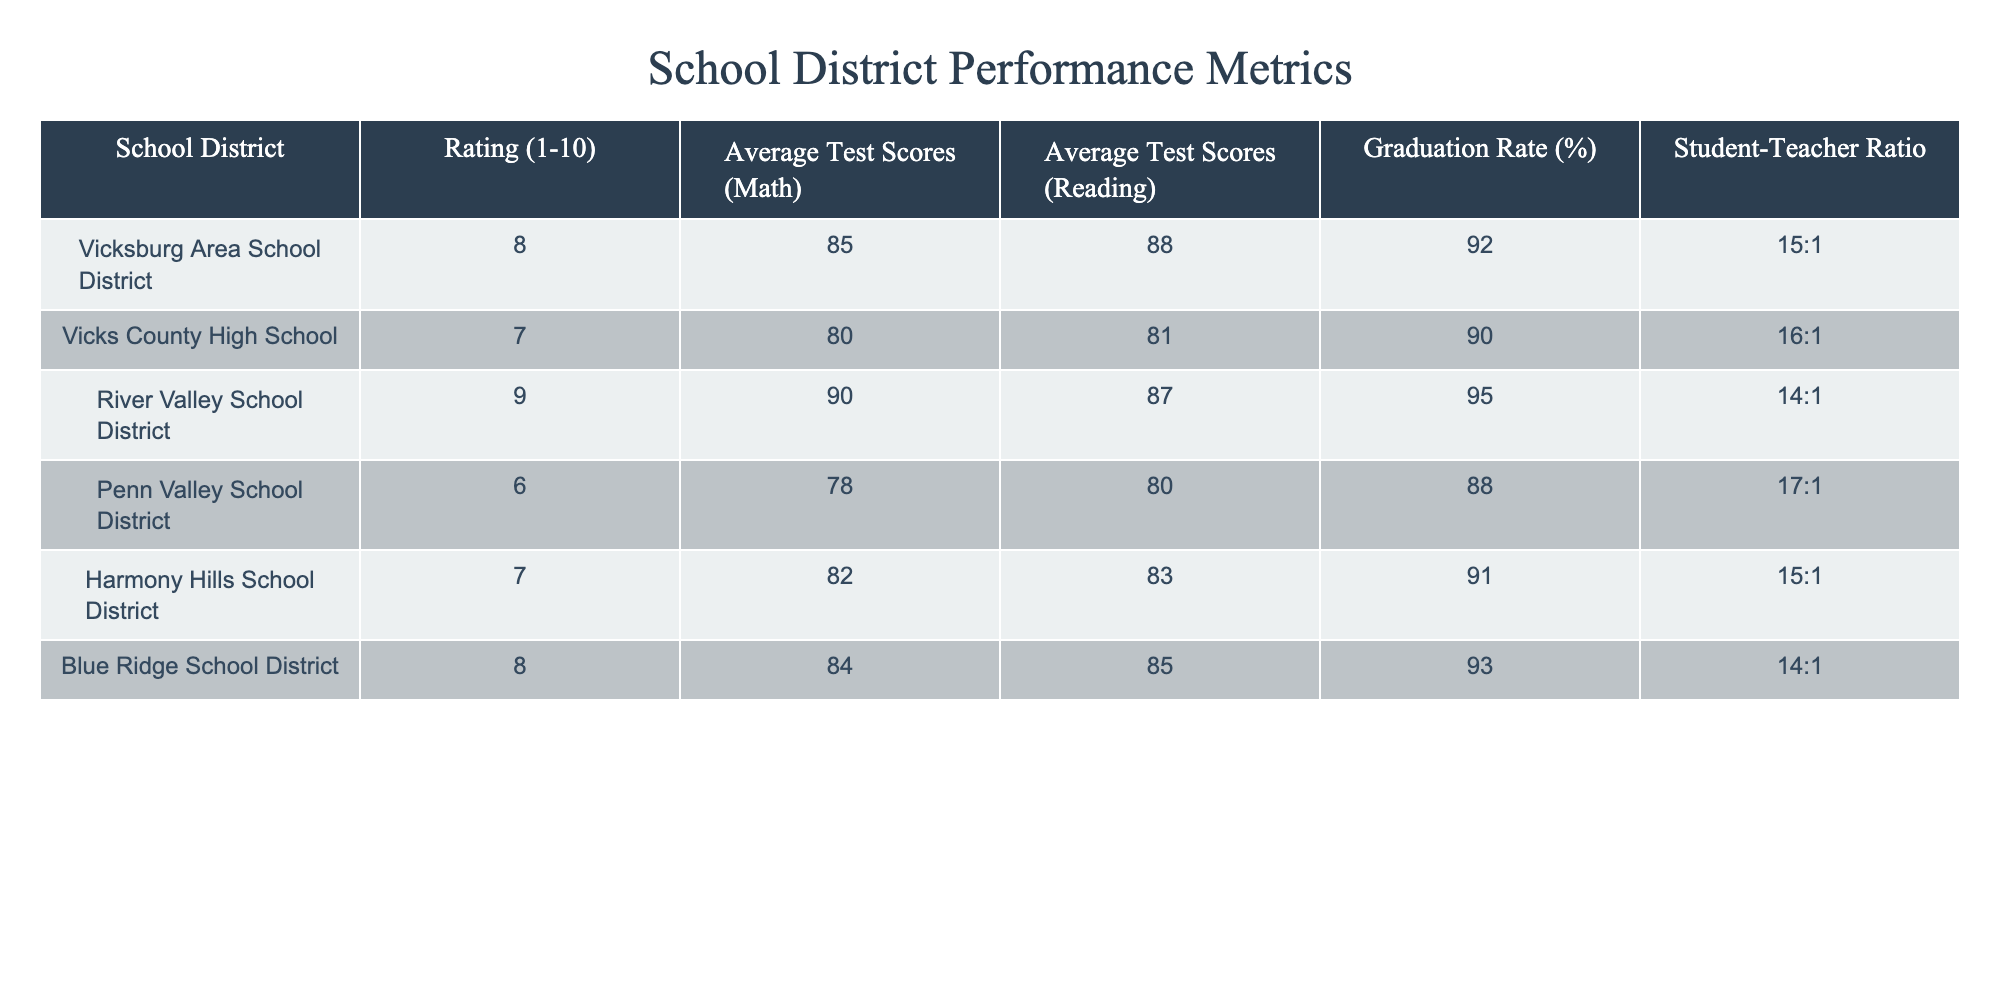What is the highest graduation rate among the school districts? The graduation rates for the districts are 92%, 90%, 95%, 88%, 91%, and 93%. The highest is 95% from the River Valley School District.
Answer: 95% What is the average student-teacher ratio across all districts? The student-teacher ratios are 15:1, 16:1, 14:1, 17:1, 15:1, and 14:1. Converting these to decimals: 15, 16, 14, 17, 15, 14. The sum is 91. There are 6 districts, so the average is 91/6 = 15.17.
Answer: 15.17 Is the Vicksburg Area School District rated higher than the Vicks County High School? The Vicksburg Area School District has a rating of 8, while Vicks County High School has a rating of 7. Since 8 is greater than 7, the statement is true.
Answer: Yes Which school district has the second highest average reading score? The average reading scores are 88, 81, 87, 80, 83, and 85. The highest is 90, followed by 88 for Vicksburg Area School District. The second highest is 87 for River Valley School District.
Answer: River Valley School District What is the difference in average math scores between the highest and lowest rated school districts? The highest math score is 90 from the River Valley School District and the lowest is 78 from Penn Valley School District. The difference is 90 - 78 = 12.
Answer: 12 Does any school district have a graduation rate of less than 90%? The graduation rates are 92%, 90%, 95%, 88%, 91%, and 93%. The only one under 90% is the Penn Valley School District with a graduation rate of 88%.
Answer: Yes What is the average test score in math for districts rated 7 or lower? The math scores for districts rated 7 or lower (Vicks County High School, Penn Valley School District, Harmony Hills School District) are 80, 78, and 82. Their sum is 240 and the average is 240/3 = 80.
Answer: 80 Which district has a better average reading score: Blue Ridge School District or Harmony Hills School District? Blue Ridge School District has an average reading score of 85 while Harmony Hills School District has 83. Therefore, Blue Ridge performs better in reading.
Answer: Blue Ridge School District 